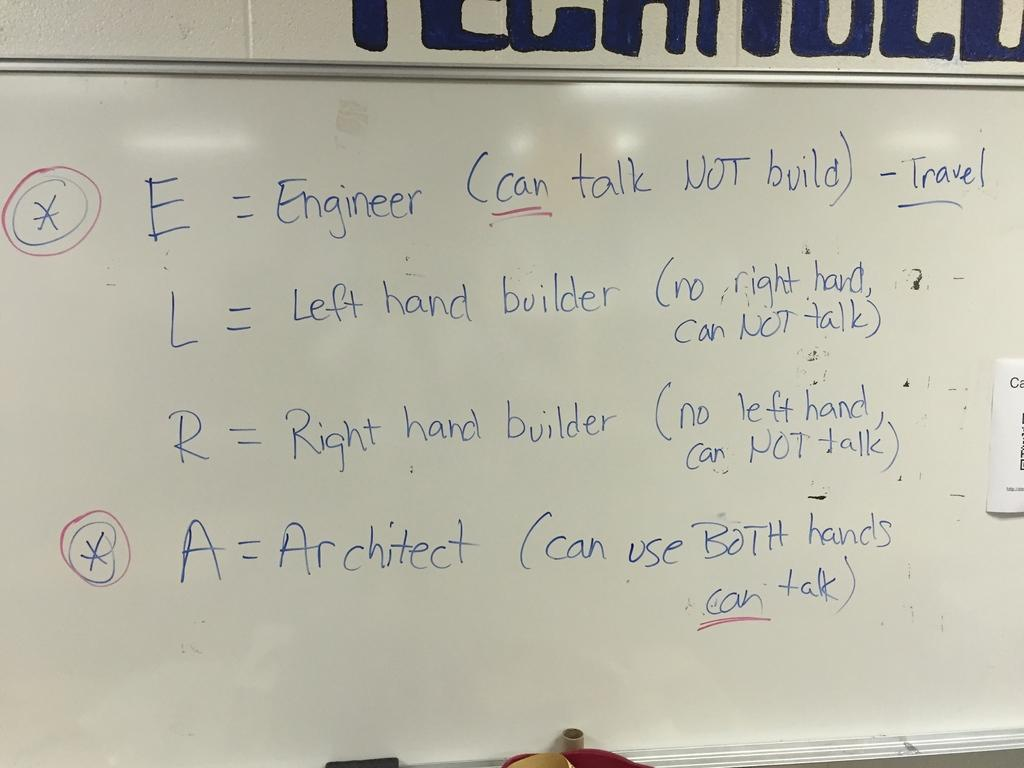<image>
Share a concise interpretation of the image provided. White board that has the word Engineer in blue letters. 